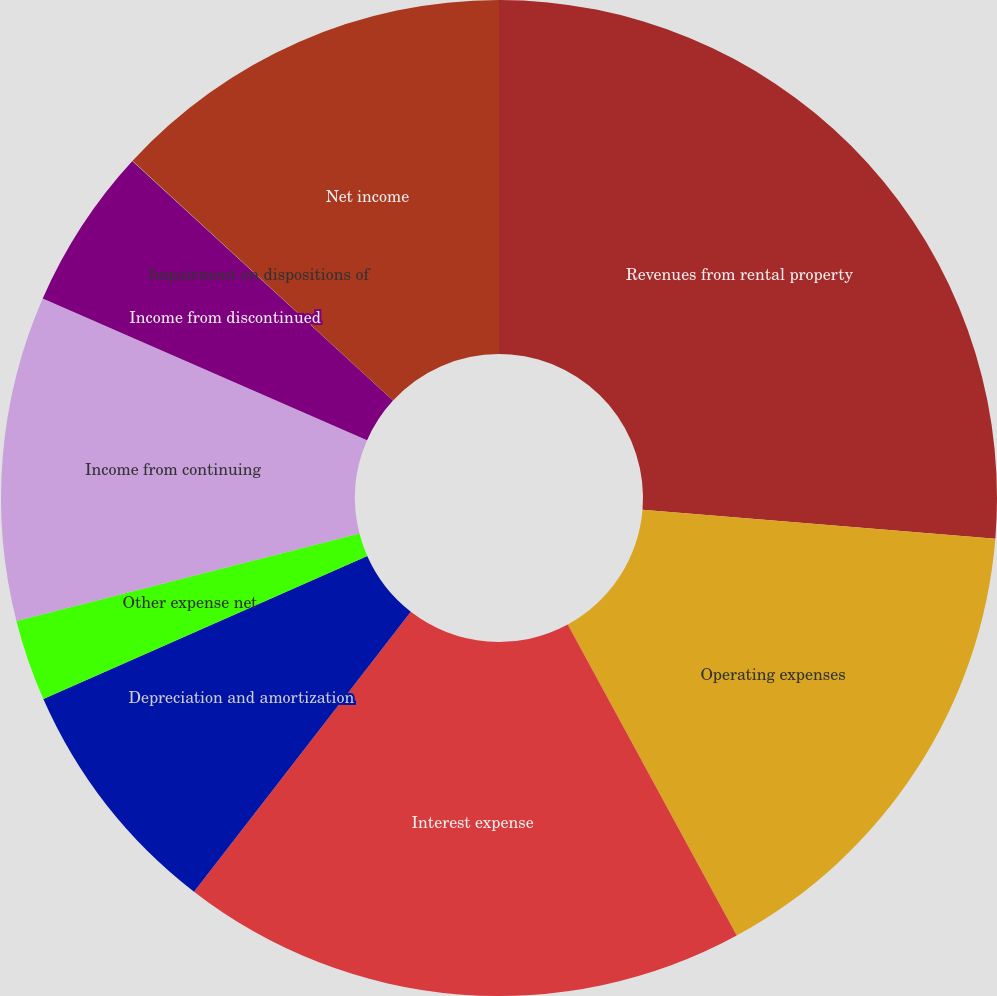Convert chart. <chart><loc_0><loc_0><loc_500><loc_500><pie_chart><fcel>Revenues from rental property<fcel>Operating expenses<fcel>Interest expense<fcel>Depreciation and amortization<fcel>Other expense net<fcel>Income from continuing<fcel>Income from discontinued<fcel>Impairment on dispositions of<fcel>Net income<nl><fcel>26.3%<fcel>15.78%<fcel>18.41%<fcel>7.9%<fcel>2.64%<fcel>10.53%<fcel>5.27%<fcel>0.01%<fcel>13.16%<nl></chart> 